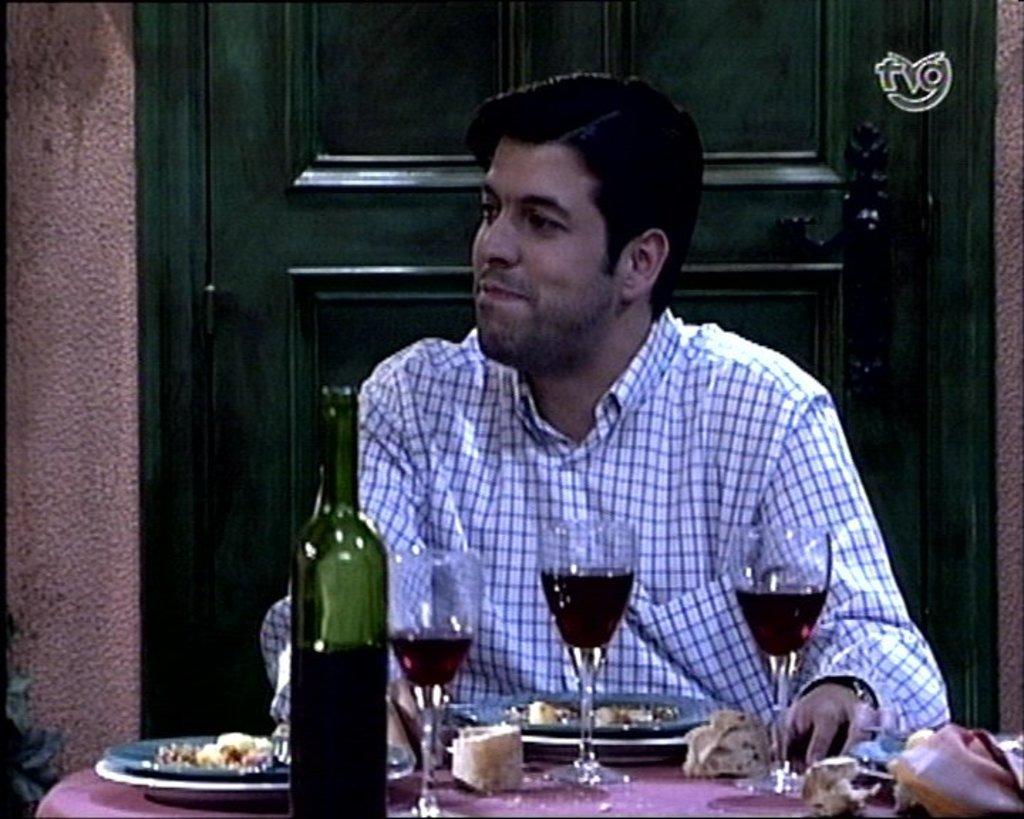Can you describe this image briefly? There is a man sitting on the chair. This is table. On the table there are glasses, plates, and a bottle. On the background there is a door and this is wall. 